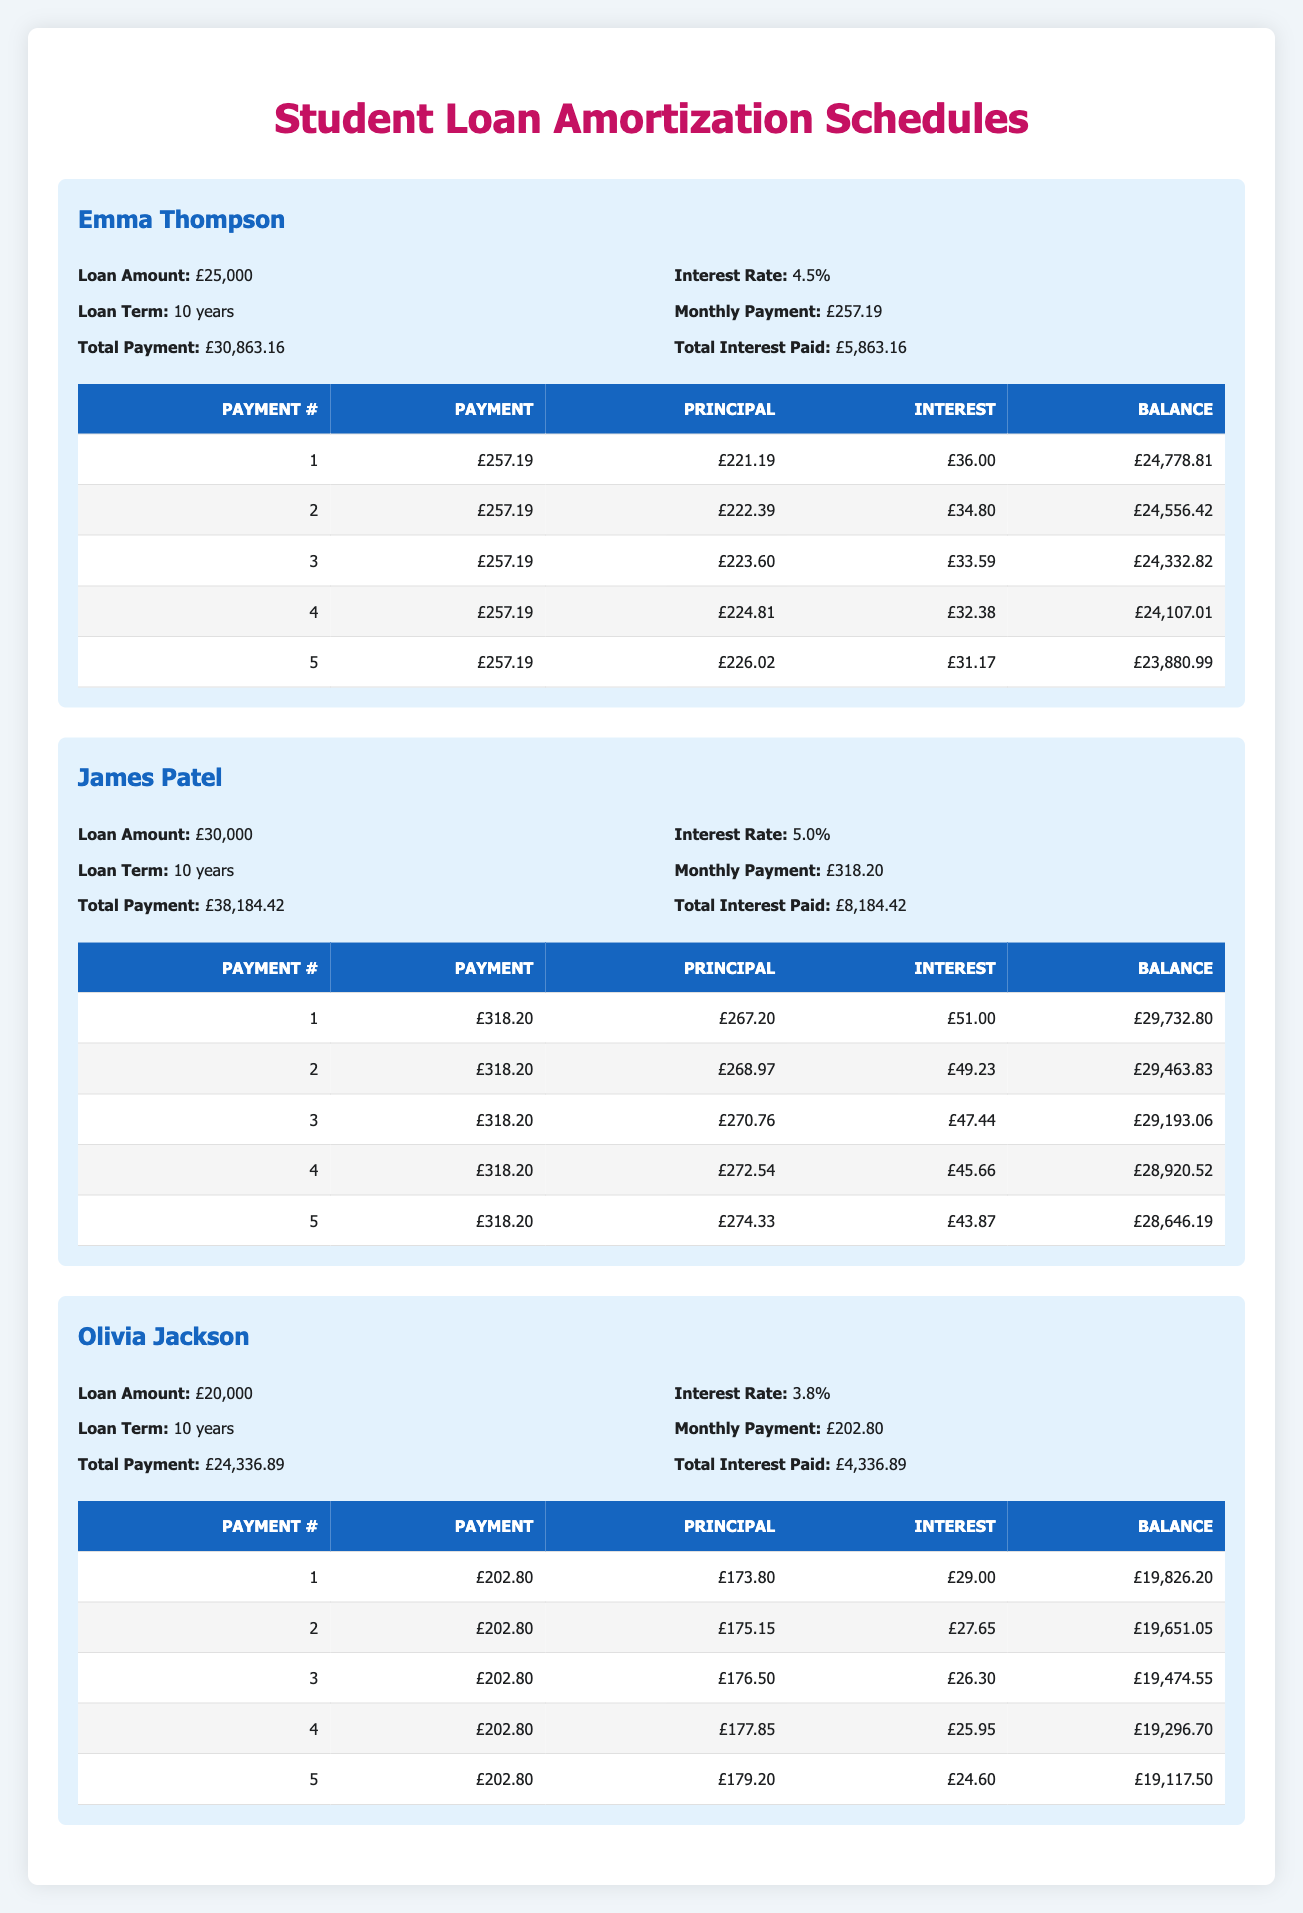What is the total amount paid by Emma Thompson over the term of her loan? To find the total amount paid by Emma Thompson, we look at the "Total Payment" value associated with her loan. According to the table, her total payment is £30,863.16.
Answer: £30,863.16 What is the monthly payment for James Patel's loan? The monthly payment is explicitly listed in the table under "Monthly Payment" for James Patel's loan. It is £318.20.
Answer: £318.20 Is the interest rate for Olivia Jackson's loan higher than the interest rate for Emma Thompson's loan? To answer this, we compare the interest rates listed for both loans. Olivia Jackson's loan has an interest rate of 3.8%, while Emma Thompson's loan has an interest rate of 4.5%. Since 3.8% is not higher than 4.5%, the answer is no.
Answer: No What is the difference in total interest paid between James Patel and Olivia Jackson? First, we find the total interest paid for both graduates: James Patel paid £8,184.42 and Olivia Jackson paid £4,336.89. The difference is calculated as follows: £8,184.42 - £4,336.89 = £3,847.53.
Answer: £3,847.53 What is the balance remaining after the third payment for Emma Thompson? We look at the balance after the third payment in Emma Thompson's payment schedule. It is listed as £24,332.82.
Answer: £24,332.82 Which graduate has the highest loan amount and what is that amount? By comparing the loan amounts for each graduate, we see that James Patel has the highest loan amount of £30,000.
Answer: £30,000 How much principal does Olivia Jackson pay off in her first payment? The first payment for Olivia Jackson is listed, and from that, we can see the amount applied to principal is £173.80.
Answer: £173.80 What is the total payment amount over ten years for each graduate combined? We add the total payments for all three graduates: £30,863.16 (Emma) + £38,184.42 (James) + £24,336.89 (Olivia) = £93,384.47.
Answer: £93,384.47 What was the percentage of the first payment that went towards interest for James Patel? The first payment was £318.20, and the interest for that payment was £51.00. To find the percentage that went towards interest: (51 / 318.20) * 100 ≈ 16.03%.
Answer: Approximately 16.03% 